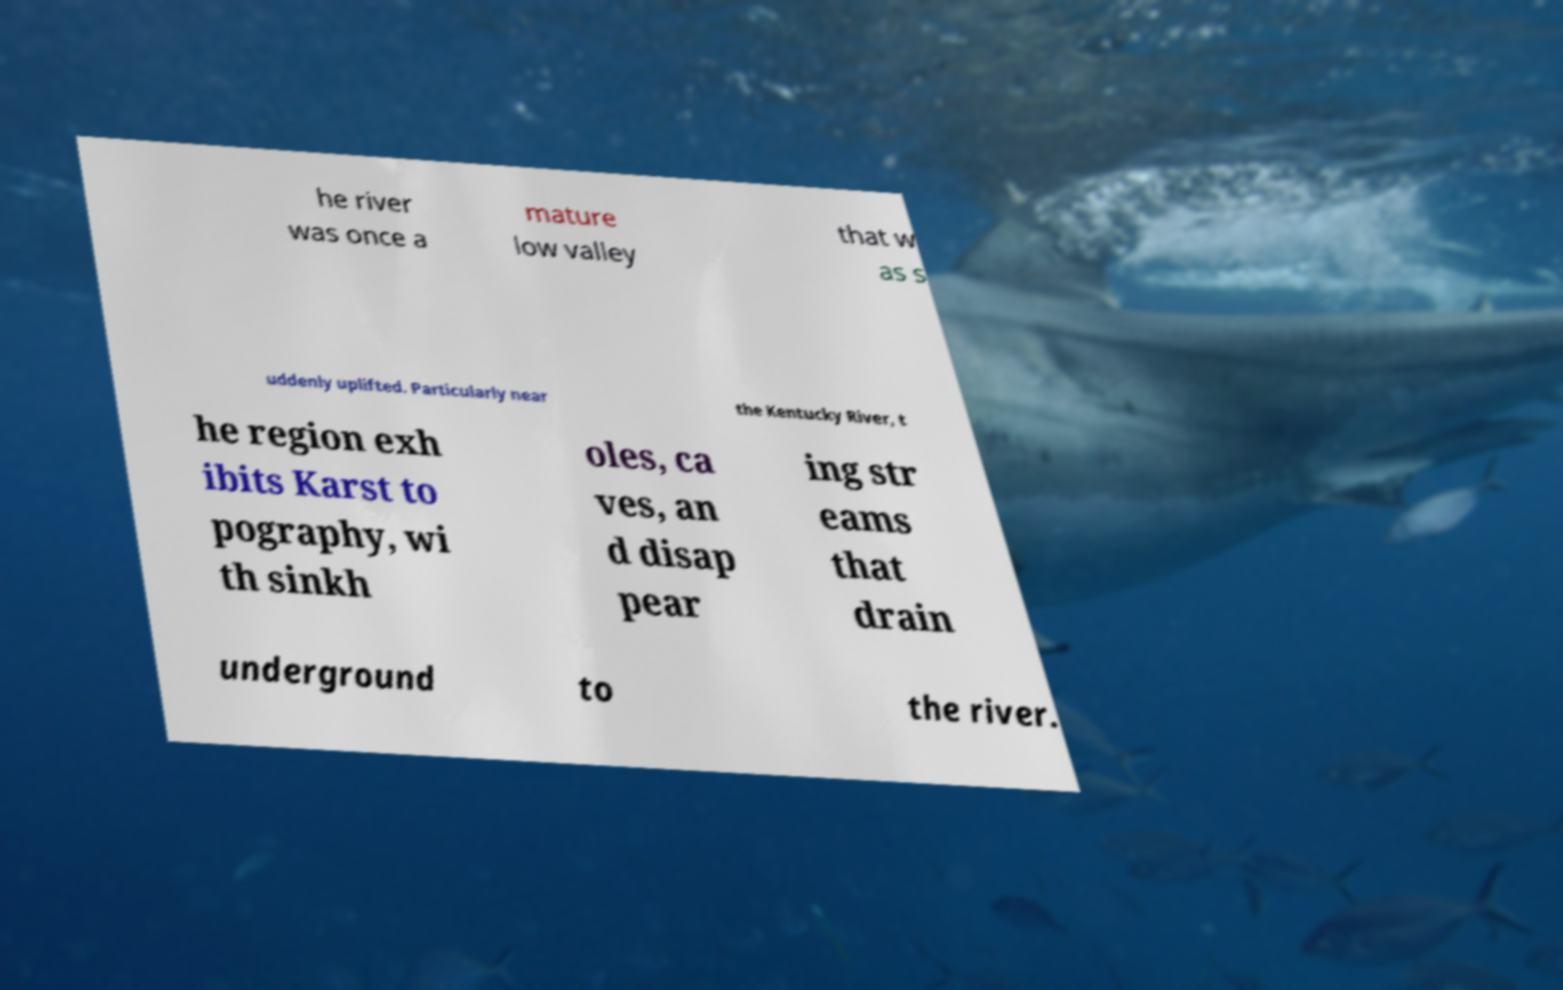Could you assist in decoding the text presented in this image and type it out clearly? he river was once a mature low valley that w as s uddenly uplifted. Particularly near the Kentucky River, t he region exh ibits Karst to pography, wi th sinkh oles, ca ves, an d disap pear ing str eams that drain underground to the river. 